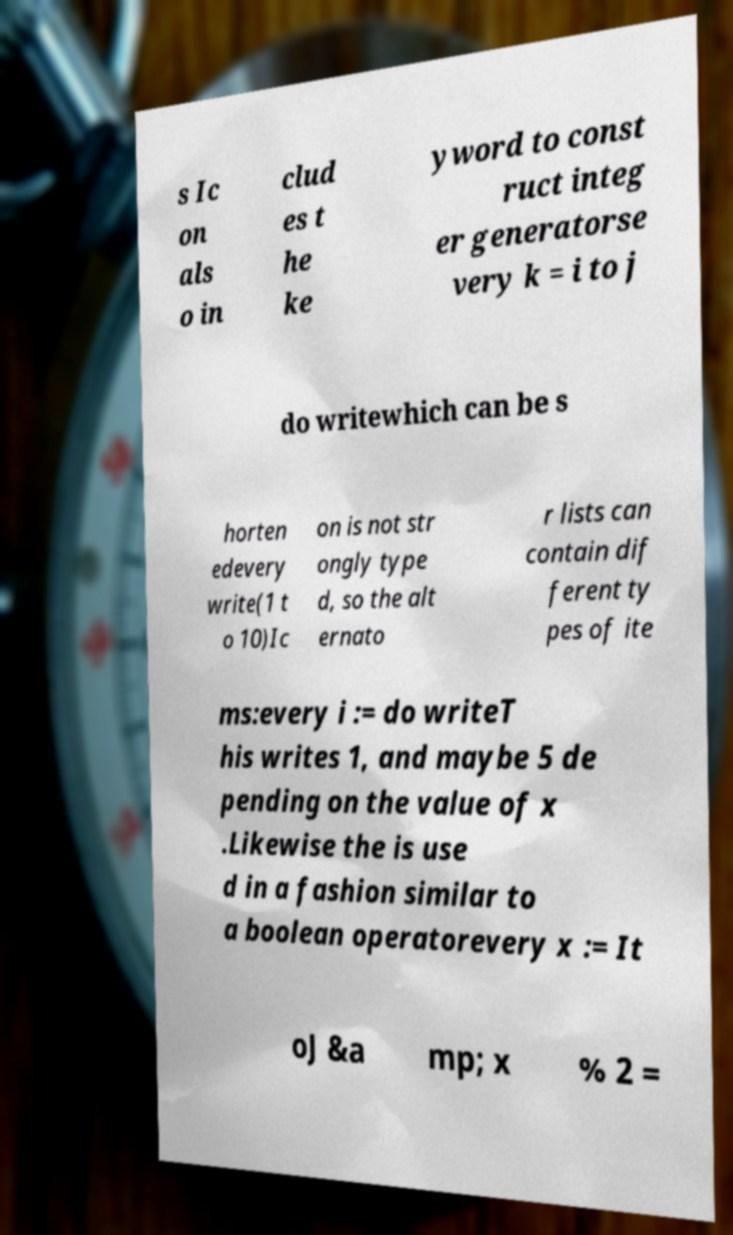Please identify and transcribe the text found in this image. s Ic on als o in clud es t he ke yword to const ruct integ er generatorse very k = i to j do writewhich can be s horten edevery write(1 t o 10)Ic on is not str ongly type d, so the alt ernato r lists can contain dif ferent ty pes of ite ms:every i := do writeT his writes 1, and maybe 5 de pending on the value of x .Likewise the is use d in a fashion similar to a boolean operatorevery x := It oJ &a mp; x % 2 = 